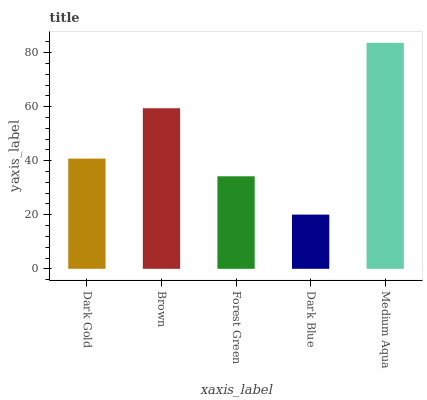Is Dark Blue the minimum?
Answer yes or no. Yes. Is Medium Aqua the maximum?
Answer yes or no. Yes. Is Brown the minimum?
Answer yes or no. No. Is Brown the maximum?
Answer yes or no. No. Is Brown greater than Dark Gold?
Answer yes or no. Yes. Is Dark Gold less than Brown?
Answer yes or no. Yes. Is Dark Gold greater than Brown?
Answer yes or no. No. Is Brown less than Dark Gold?
Answer yes or no. No. Is Dark Gold the high median?
Answer yes or no. Yes. Is Dark Gold the low median?
Answer yes or no. Yes. Is Forest Green the high median?
Answer yes or no. No. Is Dark Blue the low median?
Answer yes or no. No. 